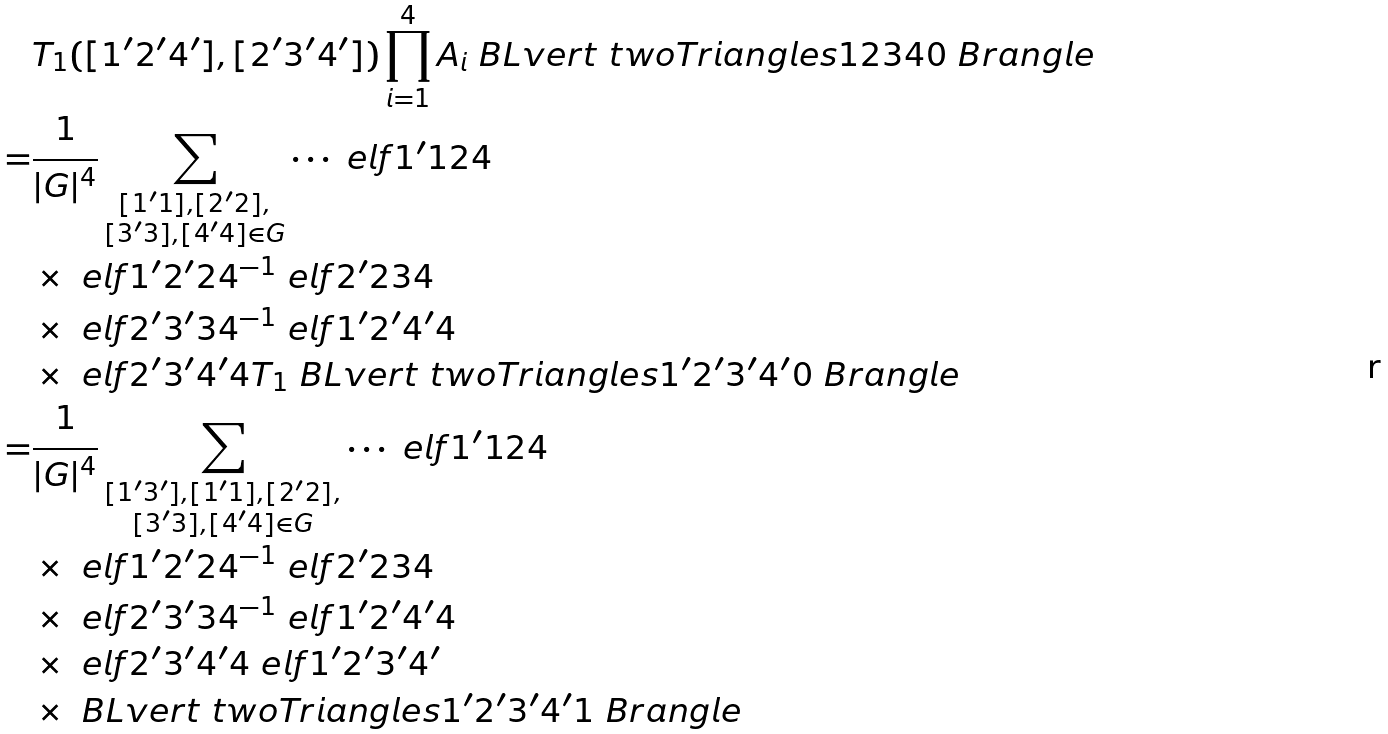<formula> <loc_0><loc_0><loc_500><loc_500>& T _ { 1 } ( [ 1 ^ { \prime } 2 ^ { \prime } 4 ^ { \prime } ] , [ 2 ^ { \prime } 3 ^ { \prime } 4 ^ { \prime } ] ) \prod _ { i = 1 } ^ { 4 } A _ { i } \ B L v e r t \ t w o T r i a n g l e s { 1 } { 2 } { 3 } { 4 } { 0 } \ B r a n g l e \\ = & \frac { 1 } { | G | ^ { 4 } } \sum _ { \substack { [ 1 ^ { \prime } 1 ] , [ 2 ^ { \prime } 2 ] , \\ [ 3 ^ { \prime } 3 ] , [ 4 ^ { \prime } 4 ] \in G } } \cdots \ e l f { 1 ^ { \prime } } { 1 } { 2 } { 4 } \\ & \times \ e l f { 1 ^ { \prime } } { 2 ^ { \prime } } { 2 } { 4 } ^ { - 1 } \ e l f { 2 ^ { \prime } } { 2 } { 3 } { 4 } \\ & \times \ e l f { 2 ^ { \prime } } { 3 ^ { \prime } } { 3 } { 4 } ^ { - 1 } \ e l f { 1 ^ { \prime } } { 2 ^ { \prime } } { 4 ^ { \prime } } { 4 } \\ & \times \ e l f { 2 ^ { \prime } } { 3 ^ { \prime } } { 4 ^ { \prime } } { 4 } T _ { 1 } \ B L v e r t \ t w o T r i a n g l e s { 1 ^ { \prime } } { 2 ^ { \prime } } { 3 ^ { \prime } } { 4 ^ { \prime } } { 0 } \ B r a n g l e \\ = & \frac { 1 } { | G | ^ { 4 } } \sum _ { \substack { [ 1 ^ { \prime } 3 ^ { \prime } ] , [ 1 ^ { \prime } 1 ] , [ 2 ^ { \prime } 2 ] , \\ [ 3 ^ { \prime } 3 ] , [ 4 ^ { \prime } 4 ] \in G } } \cdots \ e l f { 1 ^ { \prime } } { 1 } { 2 } { 4 } \\ & \times \ e l f { 1 ^ { \prime } } { 2 ^ { \prime } } { 2 } { 4 } ^ { - 1 } \ e l f { 2 ^ { \prime } } { 2 } { 3 } { 4 } \\ & \times \ e l f { 2 ^ { \prime } } { 3 ^ { \prime } } { 3 } { 4 } ^ { - 1 } \ e l f { 1 ^ { \prime } } { 2 ^ { \prime } } { 4 ^ { \prime } } { 4 } \\ & \times \ e l f { 2 ^ { \prime } } { 3 ^ { \prime } } { 4 ^ { \prime } } { 4 } \ e l f { 1 ^ { \prime } } { 2 ^ { \prime } } { 3 ^ { \prime } } { 4 ^ { \prime } } \\ & \times \ B L v e r t \ t w o T r i a n g l e s { 1 ^ { \prime } } { 2 ^ { \prime } } { 3 ^ { \prime } } { 4 ^ { \prime } } { 1 } \ B r a n g l e</formula> 